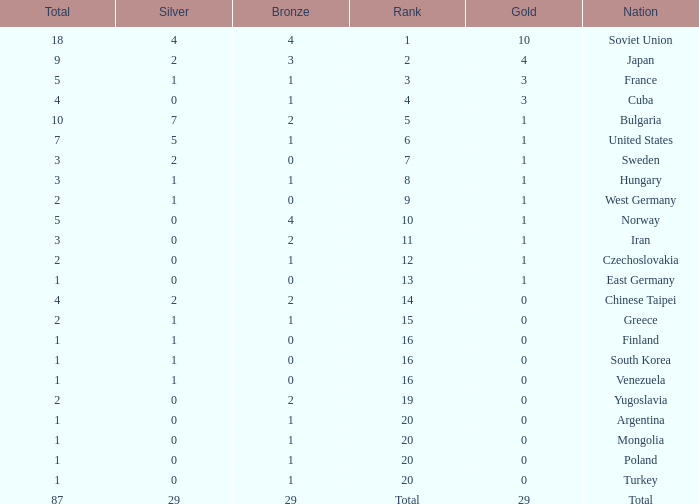What is the sum of gold medals for a rank of 14? 0.0. Give me the full table as a dictionary. {'header': ['Total', 'Silver', 'Bronze', 'Rank', 'Gold', 'Nation'], 'rows': [['18', '4', '4', '1', '10', 'Soviet Union'], ['9', '2', '3', '2', '4', 'Japan'], ['5', '1', '1', '3', '3', 'France'], ['4', '0', '1', '4', '3', 'Cuba'], ['10', '7', '2', '5', '1', 'Bulgaria'], ['7', '5', '1', '6', '1', 'United States'], ['3', '2', '0', '7', '1', 'Sweden'], ['3', '1', '1', '8', '1', 'Hungary'], ['2', '1', '0', '9', '1', 'West Germany'], ['5', '0', '4', '10', '1', 'Norway'], ['3', '0', '2', '11', '1', 'Iran'], ['2', '0', '1', '12', '1', 'Czechoslovakia'], ['1', '0', '0', '13', '1', 'East Germany'], ['4', '2', '2', '14', '0', 'Chinese Taipei'], ['2', '1', '1', '15', '0', 'Greece'], ['1', '1', '0', '16', '0', 'Finland'], ['1', '1', '0', '16', '0', 'South Korea'], ['1', '1', '0', '16', '0', 'Venezuela'], ['2', '0', '2', '19', '0', 'Yugoslavia'], ['1', '0', '1', '20', '0', 'Argentina'], ['1', '0', '1', '20', '0', 'Mongolia'], ['1', '0', '1', '20', '0', 'Poland'], ['1', '0', '1', '20', '0', 'Turkey'], ['87', '29', '29', 'Total', '29', 'Total']]} 